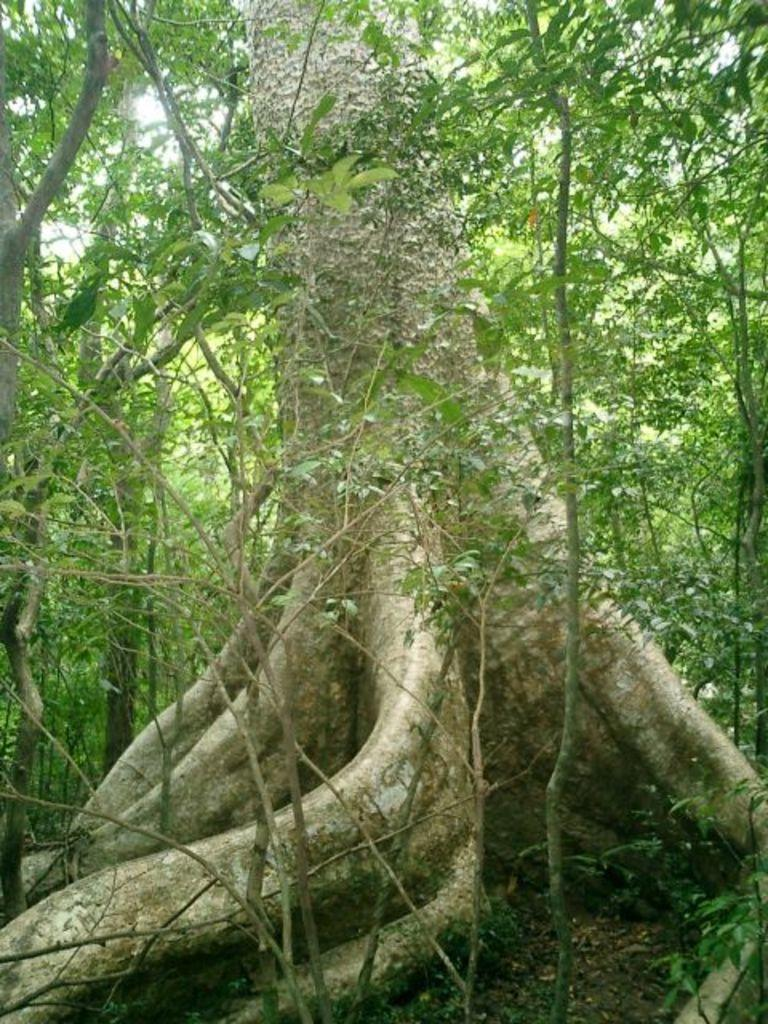What is the main subject in the middle of the image? There is a tree stem in the middle of the image. What can be seen in the background of the image? There are many trees in the background of the image. What type of environment might the image depict? The image might have been taken in a forest. What type of flowers can be seen growing on the tree stem in the image? There are no flowers visible on the tree stem in the image. What cause might have led to the trees in the background of the image? The provided facts do not mention any causes for the presence of trees in the background of the image. 